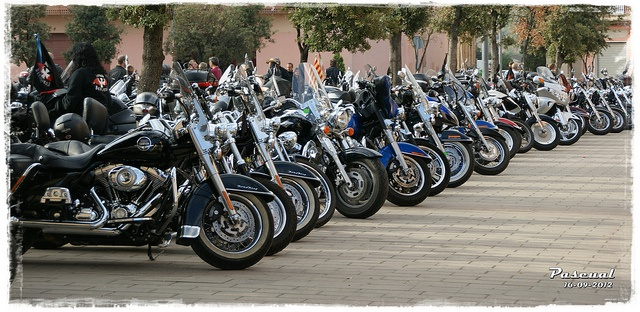Describe the objects in this image and their specific colors. I can see motorcycle in white, black, gray, darkgray, and lightgray tones, motorcycle in white, black, gray, darkgray, and lightgray tones, motorcycle in white, black, gray, darkgray, and navy tones, motorcycle in white, black, gray, darkgray, and lightgray tones, and motorcycle in white, black, darkgray, gray, and lightgray tones in this image. 